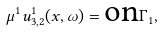Convert formula to latex. <formula><loc_0><loc_0><loc_500><loc_500>\mu ^ { 1 } u _ { 3 , 2 } ^ { 1 } ( x , \omega ) = \text {on} \Gamma _ { 1 } ,</formula> 